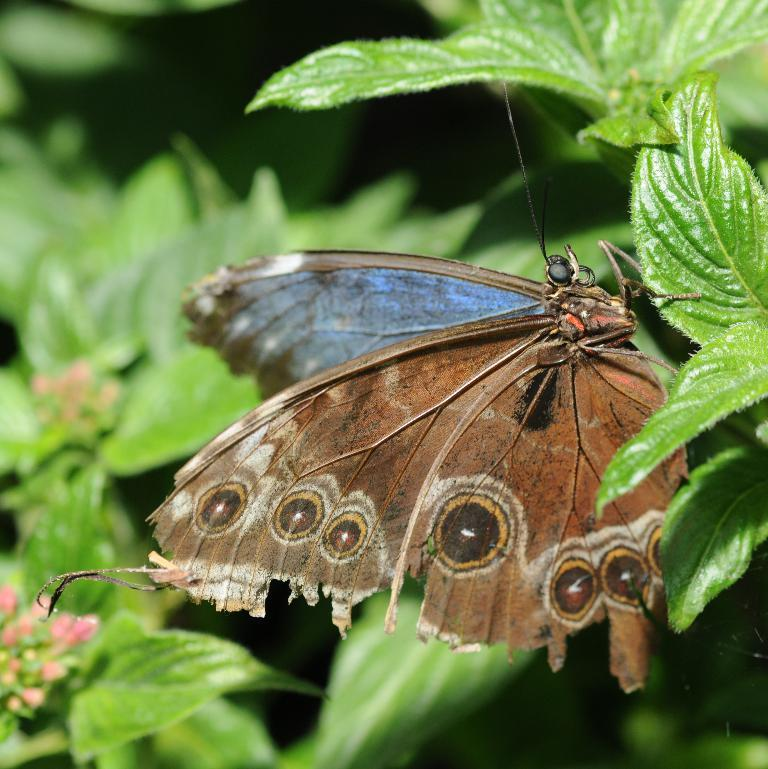What type of animal can be seen on a leaf in the image? There is a butterfly on a leaf in the image. What type of plants are present in the image? There are plants with flowers and plants with buds in the image. How does the butterfly help the island in the image? The image does not depict an island, and the butterfly is not shown helping any island. 